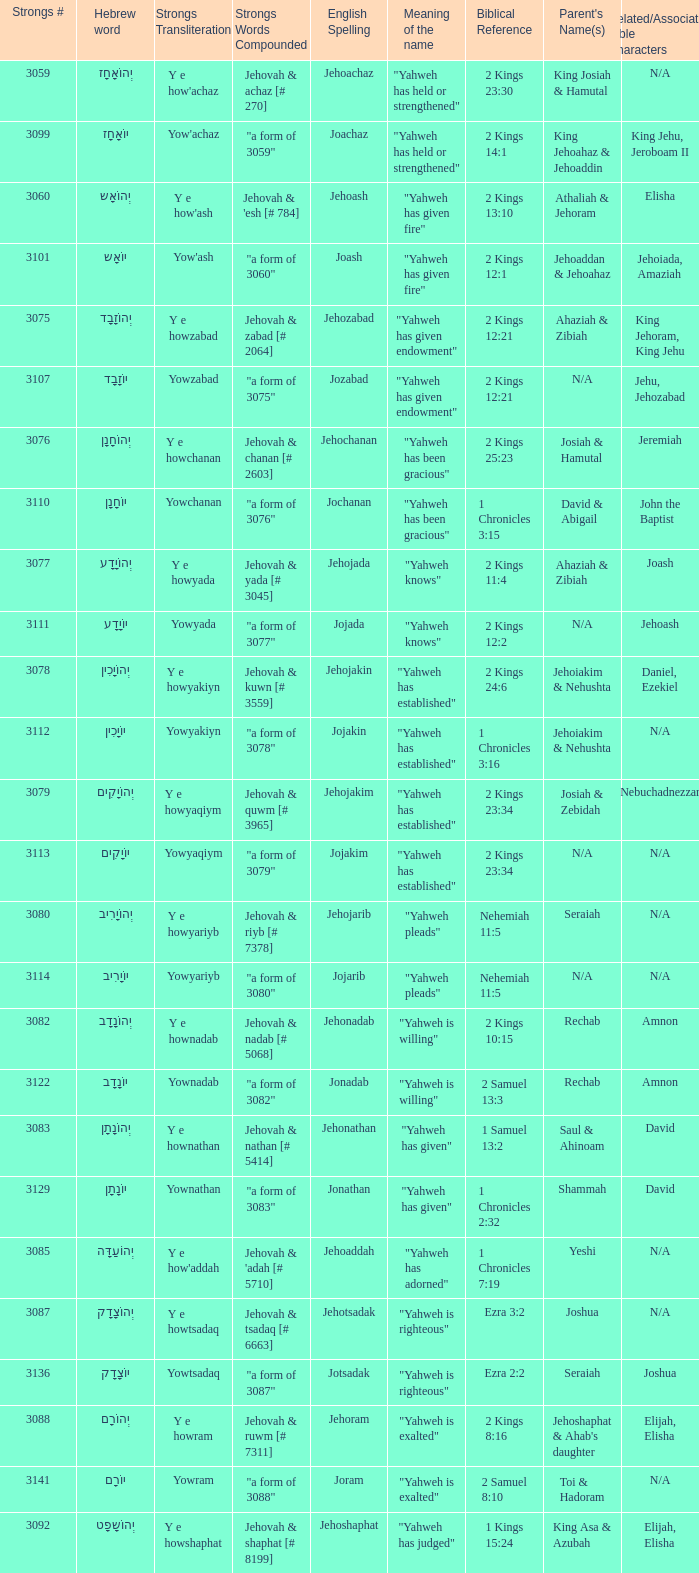What is the strongs transliteration of the hebrew word יוֹחָנָן? Yowchanan. 